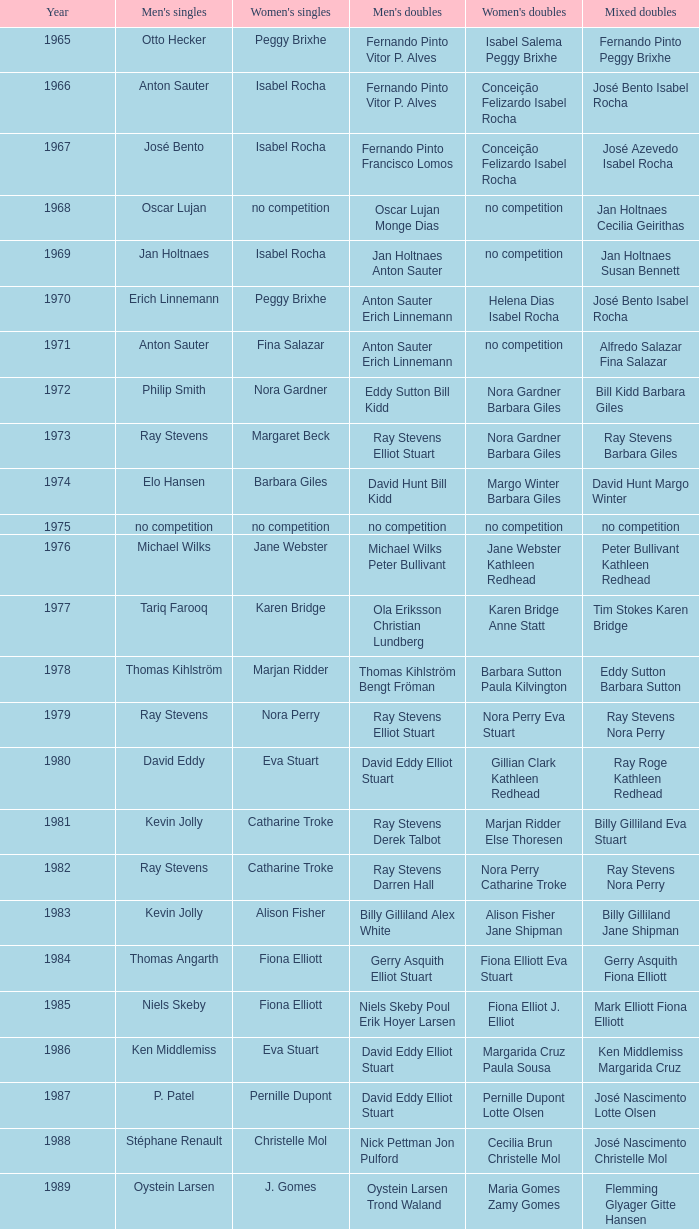What is the mean year with alfredo salazar fina salazar in mixed doubles? 1971.0. 